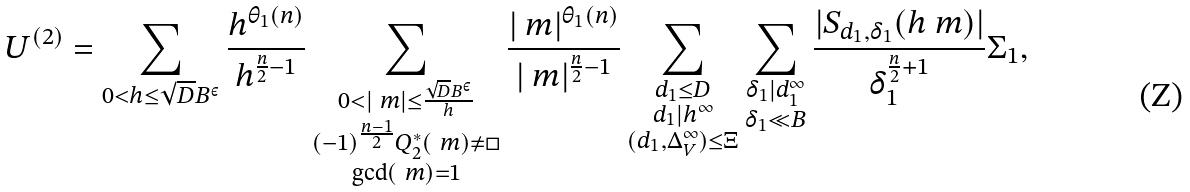<formula> <loc_0><loc_0><loc_500><loc_500>U ^ { ( 2 ) } = \sum _ { 0 < h \leq \sqrt { D } B ^ { \varepsilon } } \frac { h ^ { \theta _ { 1 } ( n ) } } { h ^ { \frac { n } { 2 } - 1 } } \sum _ { \substack { 0 < | \ m | \leq \frac { \sqrt { D } B ^ { \varepsilon } } { h } \\ ( - 1 ) ^ { \frac { n - 1 } { 2 } } Q ^ { * } _ { 2 } ( \ m ) \neq \square \\ \gcd ( \ m ) = 1 } } \frac { | \ m | ^ { \theta _ { 1 } ( n ) } } { | \ m | ^ { \frac { n } { 2 } - 1 } } \sum _ { \substack { d _ { 1 } \leq D \\ d _ { 1 } | h ^ { \infty } \\ ( d _ { 1 } , \Delta _ { V } ^ { \infty } ) \leq \Xi } } \sum _ { \substack { \delta _ { 1 } | d _ { 1 } ^ { \infty } \\ \delta _ { 1 } \ll B } } \frac { | S _ { d _ { 1 } , \delta _ { 1 } } ( h \ m ) | } { \delta _ { 1 } ^ { \frac { n } { 2 } + 1 } } \Sigma _ { 1 } ,</formula> 